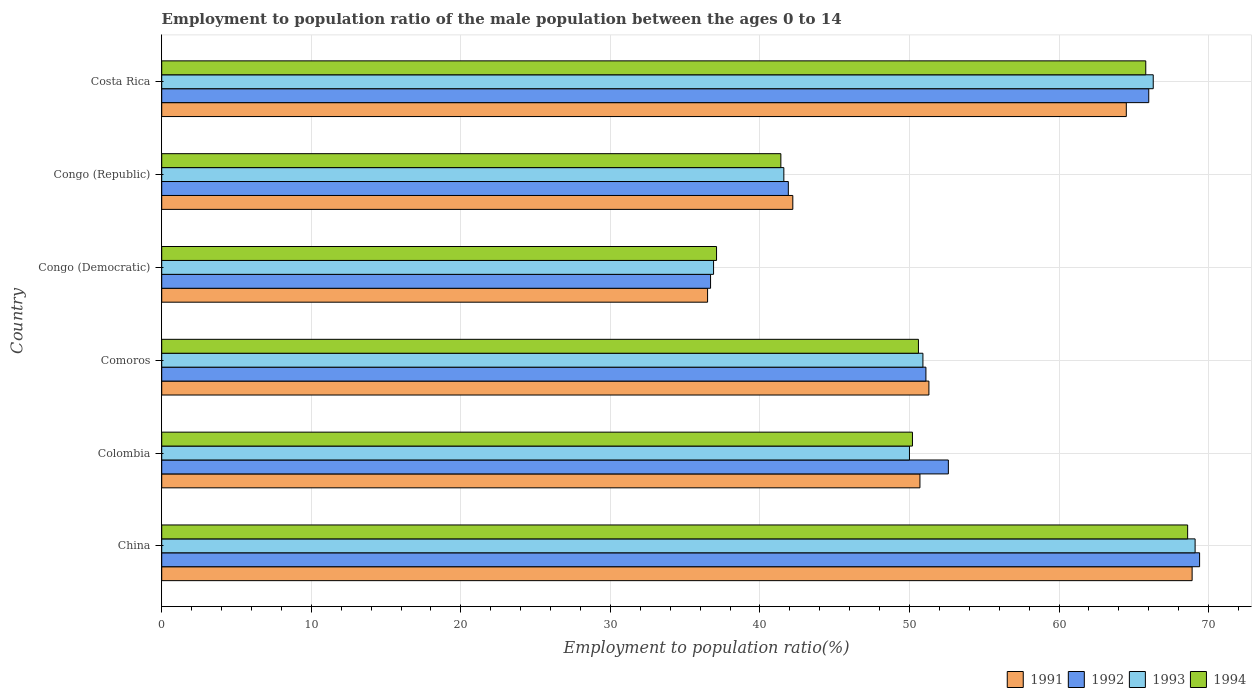Are the number of bars on each tick of the Y-axis equal?
Your answer should be compact. Yes. How many bars are there on the 4th tick from the top?
Make the answer very short. 4. How many bars are there on the 5th tick from the bottom?
Keep it short and to the point. 4. What is the label of the 6th group of bars from the top?
Ensure brevity in your answer.  China. What is the employment to population ratio in 1994 in Comoros?
Keep it short and to the point. 50.6. Across all countries, what is the maximum employment to population ratio in 1994?
Provide a short and direct response. 68.6. Across all countries, what is the minimum employment to population ratio in 1991?
Offer a terse response. 36.5. In which country was the employment to population ratio in 1994 maximum?
Provide a succinct answer. China. In which country was the employment to population ratio in 1991 minimum?
Keep it short and to the point. Congo (Democratic). What is the total employment to population ratio in 1992 in the graph?
Provide a short and direct response. 317.7. What is the difference between the employment to population ratio in 1994 in China and that in Congo (Republic)?
Make the answer very short. 27.2. What is the difference between the employment to population ratio in 1992 in Congo (Republic) and the employment to population ratio in 1994 in China?
Offer a terse response. -26.7. What is the average employment to population ratio in 1991 per country?
Your answer should be very brief. 52.35. What is the ratio of the employment to population ratio in 1992 in China to that in Congo (Democratic)?
Offer a very short reply. 1.89. Is the employment to population ratio in 1994 in Congo (Democratic) less than that in Congo (Republic)?
Ensure brevity in your answer.  Yes. What is the difference between the highest and the second highest employment to population ratio in 1994?
Provide a short and direct response. 2.8. What is the difference between the highest and the lowest employment to population ratio in 1991?
Keep it short and to the point. 32.4. Is the sum of the employment to population ratio in 1994 in Colombia and Comoros greater than the maximum employment to population ratio in 1991 across all countries?
Ensure brevity in your answer.  Yes. Is it the case that in every country, the sum of the employment to population ratio in 1993 and employment to population ratio in 1994 is greater than the sum of employment to population ratio in 1992 and employment to population ratio in 1991?
Keep it short and to the point. No. What does the 3rd bar from the top in Comoros represents?
Make the answer very short. 1992. What does the 2nd bar from the bottom in China represents?
Provide a succinct answer. 1992. How many bars are there?
Give a very brief answer. 24. Are all the bars in the graph horizontal?
Offer a terse response. Yes. Are the values on the major ticks of X-axis written in scientific E-notation?
Offer a very short reply. No. Does the graph contain grids?
Give a very brief answer. Yes. Where does the legend appear in the graph?
Your answer should be very brief. Bottom right. How are the legend labels stacked?
Your response must be concise. Horizontal. What is the title of the graph?
Your response must be concise. Employment to population ratio of the male population between the ages 0 to 14. What is the label or title of the Y-axis?
Provide a short and direct response. Country. What is the Employment to population ratio(%) in 1991 in China?
Make the answer very short. 68.9. What is the Employment to population ratio(%) in 1992 in China?
Your answer should be very brief. 69.4. What is the Employment to population ratio(%) in 1993 in China?
Provide a succinct answer. 69.1. What is the Employment to population ratio(%) in 1994 in China?
Provide a short and direct response. 68.6. What is the Employment to population ratio(%) in 1991 in Colombia?
Make the answer very short. 50.7. What is the Employment to population ratio(%) of 1992 in Colombia?
Ensure brevity in your answer.  52.6. What is the Employment to population ratio(%) of 1994 in Colombia?
Offer a very short reply. 50.2. What is the Employment to population ratio(%) of 1991 in Comoros?
Give a very brief answer. 51.3. What is the Employment to population ratio(%) in 1992 in Comoros?
Make the answer very short. 51.1. What is the Employment to population ratio(%) of 1993 in Comoros?
Provide a succinct answer. 50.9. What is the Employment to population ratio(%) of 1994 in Comoros?
Provide a short and direct response. 50.6. What is the Employment to population ratio(%) in 1991 in Congo (Democratic)?
Make the answer very short. 36.5. What is the Employment to population ratio(%) in 1992 in Congo (Democratic)?
Your answer should be very brief. 36.7. What is the Employment to population ratio(%) of 1993 in Congo (Democratic)?
Provide a succinct answer. 36.9. What is the Employment to population ratio(%) of 1994 in Congo (Democratic)?
Give a very brief answer. 37.1. What is the Employment to population ratio(%) in 1991 in Congo (Republic)?
Offer a very short reply. 42.2. What is the Employment to population ratio(%) in 1992 in Congo (Republic)?
Your response must be concise. 41.9. What is the Employment to population ratio(%) of 1993 in Congo (Republic)?
Your response must be concise. 41.6. What is the Employment to population ratio(%) of 1994 in Congo (Republic)?
Give a very brief answer. 41.4. What is the Employment to population ratio(%) in 1991 in Costa Rica?
Your response must be concise. 64.5. What is the Employment to population ratio(%) in 1992 in Costa Rica?
Ensure brevity in your answer.  66. What is the Employment to population ratio(%) of 1993 in Costa Rica?
Keep it short and to the point. 66.3. What is the Employment to population ratio(%) of 1994 in Costa Rica?
Make the answer very short. 65.8. Across all countries, what is the maximum Employment to population ratio(%) in 1991?
Your answer should be very brief. 68.9. Across all countries, what is the maximum Employment to population ratio(%) of 1992?
Make the answer very short. 69.4. Across all countries, what is the maximum Employment to population ratio(%) in 1993?
Provide a succinct answer. 69.1. Across all countries, what is the maximum Employment to population ratio(%) in 1994?
Give a very brief answer. 68.6. Across all countries, what is the minimum Employment to population ratio(%) of 1991?
Ensure brevity in your answer.  36.5. Across all countries, what is the minimum Employment to population ratio(%) in 1992?
Provide a succinct answer. 36.7. Across all countries, what is the minimum Employment to population ratio(%) of 1993?
Your response must be concise. 36.9. Across all countries, what is the minimum Employment to population ratio(%) of 1994?
Make the answer very short. 37.1. What is the total Employment to population ratio(%) in 1991 in the graph?
Provide a short and direct response. 314.1. What is the total Employment to population ratio(%) of 1992 in the graph?
Ensure brevity in your answer.  317.7. What is the total Employment to population ratio(%) of 1993 in the graph?
Provide a succinct answer. 314.8. What is the total Employment to population ratio(%) of 1994 in the graph?
Your response must be concise. 313.7. What is the difference between the Employment to population ratio(%) of 1994 in China and that in Colombia?
Make the answer very short. 18.4. What is the difference between the Employment to population ratio(%) of 1992 in China and that in Comoros?
Provide a succinct answer. 18.3. What is the difference between the Employment to population ratio(%) of 1991 in China and that in Congo (Democratic)?
Ensure brevity in your answer.  32.4. What is the difference between the Employment to population ratio(%) of 1992 in China and that in Congo (Democratic)?
Your answer should be very brief. 32.7. What is the difference between the Employment to population ratio(%) in 1993 in China and that in Congo (Democratic)?
Your answer should be very brief. 32.2. What is the difference between the Employment to population ratio(%) in 1994 in China and that in Congo (Democratic)?
Provide a short and direct response. 31.5. What is the difference between the Employment to population ratio(%) of 1991 in China and that in Congo (Republic)?
Keep it short and to the point. 26.7. What is the difference between the Employment to population ratio(%) in 1992 in China and that in Congo (Republic)?
Provide a short and direct response. 27.5. What is the difference between the Employment to population ratio(%) of 1994 in China and that in Congo (Republic)?
Give a very brief answer. 27.2. What is the difference between the Employment to population ratio(%) in 1991 in China and that in Costa Rica?
Provide a succinct answer. 4.4. What is the difference between the Employment to population ratio(%) in 1991 in Colombia and that in Comoros?
Your answer should be compact. -0.6. What is the difference between the Employment to population ratio(%) in 1992 in Colombia and that in Congo (Democratic)?
Offer a terse response. 15.9. What is the difference between the Employment to population ratio(%) in 1991 in Colombia and that in Congo (Republic)?
Your answer should be very brief. 8.5. What is the difference between the Employment to population ratio(%) of 1993 in Colombia and that in Congo (Republic)?
Offer a very short reply. 8.4. What is the difference between the Employment to population ratio(%) of 1991 in Colombia and that in Costa Rica?
Make the answer very short. -13.8. What is the difference between the Employment to population ratio(%) of 1993 in Colombia and that in Costa Rica?
Your response must be concise. -16.3. What is the difference between the Employment to population ratio(%) of 1994 in Colombia and that in Costa Rica?
Your answer should be very brief. -15.6. What is the difference between the Employment to population ratio(%) in 1992 in Comoros and that in Congo (Democratic)?
Provide a succinct answer. 14.4. What is the difference between the Employment to population ratio(%) in 1993 in Comoros and that in Congo (Democratic)?
Give a very brief answer. 14. What is the difference between the Employment to population ratio(%) of 1994 in Comoros and that in Congo (Democratic)?
Give a very brief answer. 13.5. What is the difference between the Employment to population ratio(%) of 1991 in Comoros and that in Congo (Republic)?
Provide a short and direct response. 9.1. What is the difference between the Employment to population ratio(%) of 1994 in Comoros and that in Congo (Republic)?
Your answer should be compact. 9.2. What is the difference between the Employment to population ratio(%) of 1991 in Comoros and that in Costa Rica?
Ensure brevity in your answer.  -13.2. What is the difference between the Employment to population ratio(%) of 1992 in Comoros and that in Costa Rica?
Offer a very short reply. -14.9. What is the difference between the Employment to population ratio(%) in 1993 in Comoros and that in Costa Rica?
Provide a succinct answer. -15.4. What is the difference between the Employment to population ratio(%) in 1994 in Comoros and that in Costa Rica?
Provide a succinct answer. -15.2. What is the difference between the Employment to population ratio(%) of 1992 in Congo (Democratic) and that in Congo (Republic)?
Your answer should be compact. -5.2. What is the difference between the Employment to population ratio(%) in 1993 in Congo (Democratic) and that in Congo (Republic)?
Make the answer very short. -4.7. What is the difference between the Employment to population ratio(%) in 1992 in Congo (Democratic) and that in Costa Rica?
Offer a terse response. -29.3. What is the difference between the Employment to population ratio(%) in 1993 in Congo (Democratic) and that in Costa Rica?
Your answer should be compact. -29.4. What is the difference between the Employment to population ratio(%) in 1994 in Congo (Democratic) and that in Costa Rica?
Offer a very short reply. -28.7. What is the difference between the Employment to population ratio(%) of 1991 in Congo (Republic) and that in Costa Rica?
Keep it short and to the point. -22.3. What is the difference between the Employment to population ratio(%) in 1992 in Congo (Republic) and that in Costa Rica?
Offer a terse response. -24.1. What is the difference between the Employment to population ratio(%) of 1993 in Congo (Republic) and that in Costa Rica?
Provide a short and direct response. -24.7. What is the difference between the Employment to population ratio(%) of 1994 in Congo (Republic) and that in Costa Rica?
Give a very brief answer. -24.4. What is the difference between the Employment to population ratio(%) of 1991 in China and the Employment to population ratio(%) of 1994 in Colombia?
Ensure brevity in your answer.  18.7. What is the difference between the Employment to population ratio(%) of 1993 in China and the Employment to population ratio(%) of 1994 in Colombia?
Keep it short and to the point. 18.9. What is the difference between the Employment to population ratio(%) in 1991 in China and the Employment to population ratio(%) in 1993 in Comoros?
Your answer should be very brief. 18. What is the difference between the Employment to population ratio(%) in 1992 in China and the Employment to population ratio(%) in 1993 in Comoros?
Ensure brevity in your answer.  18.5. What is the difference between the Employment to population ratio(%) in 1993 in China and the Employment to population ratio(%) in 1994 in Comoros?
Provide a short and direct response. 18.5. What is the difference between the Employment to population ratio(%) in 1991 in China and the Employment to population ratio(%) in 1992 in Congo (Democratic)?
Your response must be concise. 32.2. What is the difference between the Employment to population ratio(%) in 1991 in China and the Employment to population ratio(%) in 1994 in Congo (Democratic)?
Make the answer very short. 31.8. What is the difference between the Employment to population ratio(%) in 1992 in China and the Employment to population ratio(%) in 1993 in Congo (Democratic)?
Offer a very short reply. 32.5. What is the difference between the Employment to population ratio(%) in 1992 in China and the Employment to population ratio(%) in 1994 in Congo (Democratic)?
Ensure brevity in your answer.  32.3. What is the difference between the Employment to population ratio(%) in 1993 in China and the Employment to population ratio(%) in 1994 in Congo (Democratic)?
Your response must be concise. 32. What is the difference between the Employment to population ratio(%) in 1991 in China and the Employment to population ratio(%) in 1993 in Congo (Republic)?
Give a very brief answer. 27.3. What is the difference between the Employment to population ratio(%) of 1991 in China and the Employment to population ratio(%) of 1994 in Congo (Republic)?
Offer a terse response. 27.5. What is the difference between the Employment to population ratio(%) in 1992 in China and the Employment to population ratio(%) in 1993 in Congo (Republic)?
Provide a succinct answer. 27.8. What is the difference between the Employment to population ratio(%) in 1992 in China and the Employment to population ratio(%) in 1994 in Congo (Republic)?
Provide a short and direct response. 28. What is the difference between the Employment to population ratio(%) in 1993 in China and the Employment to population ratio(%) in 1994 in Congo (Republic)?
Give a very brief answer. 27.7. What is the difference between the Employment to population ratio(%) in 1991 in China and the Employment to population ratio(%) in 1992 in Costa Rica?
Give a very brief answer. 2.9. What is the difference between the Employment to population ratio(%) in 1991 in Colombia and the Employment to population ratio(%) in 1992 in Comoros?
Make the answer very short. -0.4. What is the difference between the Employment to population ratio(%) in 1991 in Colombia and the Employment to population ratio(%) in 1993 in Comoros?
Your response must be concise. -0.2. What is the difference between the Employment to population ratio(%) of 1992 in Colombia and the Employment to population ratio(%) of 1993 in Comoros?
Offer a terse response. 1.7. What is the difference between the Employment to population ratio(%) in 1992 in Colombia and the Employment to population ratio(%) in 1994 in Comoros?
Provide a succinct answer. 2. What is the difference between the Employment to population ratio(%) of 1993 in Colombia and the Employment to population ratio(%) of 1994 in Comoros?
Provide a short and direct response. -0.6. What is the difference between the Employment to population ratio(%) of 1991 in Colombia and the Employment to population ratio(%) of 1992 in Congo (Democratic)?
Ensure brevity in your answer.  14. What is the difference between the Employment to population ratio(%) of 1991 in Colombia and the Employment to population ratio(%) of 1993 in Congo (Republic)?
Your answer should be compact. 9.1. What is the difference between the Employment to population ratio(%) of 1992 in Colombia and the Employment to population ratio(%) of 1994 in Congo (Republic)?
Ensure brevity in your answer.  11.2. What is the difference between the Employment to population ratio(%) in 1991 in Colombia and the Employment to population ratio(%) in 1992 in Costa Rica?
Make the answer very short. -15.3. What is the difference between the Employment to population ratio(%) of 1991 in Colombia and the Employment to population ratio(%) of 1993 in Costa Rica?
Offer a very short reply. -15.6. What is the difference between the Employment to population ratio(%) of 1991 in Colombia and the Employment to population ratio(%) of 1994 in Costa Rica?
Your response must be concise. -15.1. What is the difference between the Employment to population ratio(%) of 1992 in Colombia and the Employment to population ratio(%) of 1993 in Costa Rica?
Offer a terse response. -13.7. What is the difference between the Employment to population ratio(%) of 1993 in Colombia and the Employment to population ratio(%) of 1994 in Costa Rica?
Your response must be concise. -15.8. What is the difference between the Employment to population ratio(%) of 1991 in Comoros and the Employment to population ratio(%) of 1992 in Congo (Democratic)?
Your answer should be compact. 14.6. What is the difference between the Employment to population ratio(%) of 1991 in Comoros and the Employment to population ratio(%) of 1993 in Congo (Democratic)?
Your answer should be compact. 14.4. What is the difference between the Employment to population ratio(%) in 1991 in Comoros and the Employment to population ratio(%) in 1992 in Congo (Republic)?
Your answer should be compact. 9.4. What is the difference between the Employment to population ratio(%) in 1991 in Comoros and the Employment to population ratio(%) in 1992 in Costa Rica?
Provide a short and direct response. -14.7. What is the difference between the Employment to population ratio(%) in 1992 in Comoros and the Employment to population ratio(%) in 1993 in Costa Rica?
Your answer should be very brief. -15.2. What is the difference between the Employment to population ratio(%) of 1992 in Comoros and the Employment to population ratio(%) of 1994 in Costa Rica?
Your response must be concise. -14.7. What is the difference between the Employment to population ratio(%) in 1993 in Comoros and the Employment to population ratio(%) in 1994 in Costa Rica?
Ensure brevity in your answer.  -14.9. What is the difference between the Employment to population ratio(%) in 1991 in Congo (Democratic) and the Employment to population ratio(%) in 1992 in Congo (Republic)?
Your response must be concise. -5.4. What is the difference between the Employment to population ratio(%) of 1992 in Congo (Democratic) and the Employment to population ratio(%) of 1993 in Congo (Republic)?
Make the answer very short. -4.9. What is the difference between the Employment to population ratio(%) in 1991 in Congo (Democratic) and the Employment to population ratio(%) in 1992 in Costa Rica?
Your answer should be compact. -29.5. What is the difference between the Employment to population ratio(%) in 1991 in Congo (Democratic) and the Employment to population ratio(%) in 1993 in Costa Rica?
Ensure brevity in your answer.  -29.8. What is the difference between the Employment to population ratio(%) of 1991 in Congo (Democratic) and the Employment to population ratio(%) of 1994 in Costa Rica?
Your answer should be compact. -29.3. What is the difference between the Employment to population ratio(%) of 1992 in Congo (Democratic) and the Employment to population ratio(%) of 1993 in Costa Rica?
Your answer should be very brief. -29.6. What is the difference between the Employment to population ratio(%) of 1992 in Congo (Democratic) and the Employment to population ratio(%) of 1994 in Costa Rica?
Offer a very short reply. -29.1. What is the difference between the Employment to population ratio(%) of 1993 in Congo (Democratic) and the Employment to population ratio(%) of 1994 in Costa Rica?
Give a very brief answer. -28.9. What is the difference between the Employment to population ratio(%) in 1991 in Congo (Republic) and the Employment to population ratio(%) in 1992 in Costa Rica?
Give a very brief answer. -23.8. What is the difference between the Employment to population ratio(%) of 1991 in Congo (Republic) and the Employment to population ratio(%) of 1993 in Costa Rica?
Offer a very short reply. -24.1. What is the difference between the Employment to population ratio(%) in 1991 in Congo (Republic) and the Employment to population ratio(%) in 1994 in Costa Rica?
Make the answer very short. -23.6. What is the difference between the Employment to population ratio(%) in 1992 in Congo (Republic) and the Employment to population ratio(%) in 1993 in Costa Rica?
Make the answer very short. -24.4. What is the difference between the Employment to population ratio(%) in 1992 in Congo (Republic) and the Employment to population ratio(%) in 1994 in Costa Rica?
Offer a terse response. -23.9. What is the difference between the Employment to population ratio(%) of 1993 in Congo (Republic) and the Employment to population ratio(%) of 1994 in Costa Rica?
Ensure brevity in your answer.  -24.2. What is the average Employment to population ratio(%) of 1991 per country?
Provide a succinct answer. 52.35. What is the average Employment to population ratio(%) in 1992 per country?
Provide a succinct answer. 52.95. What is the average Employment to population ratio(%) in 1993 per country?
Provide a short and direct response. 52.47. What is the average Employment to population ratio(%) in 1994 per country?
Keep it short and to the point. 52.28. What is the difference between the Employment to population ratio(%) of 1991 and Employment to population ratio(%) of 1992 in China?
Your answer should be very brief. -0.5. What is the difference between the Employment to population ratio(%) of 1991 and Employment to population ratio(%) of 1993 in China?
Give a very brief answer. -0.2. What is the difference between the Employment to population ratio(%) in 1992 and Employment to population ratio(%) in 1993 in China?
Offer a terse response. 0.3. What is the difference between the Employment to population ratio(%) of 1993 and Employment to population ratio(%) of 1994 in China?
Make the answer very short. 0.5. What is the difference between the Employment to population ratio(%) in 1991 and Employment to population ratio(%) in 1992 in Colombia?
Offer a very short reply. -1.9. What is the difference between the Employment to population ratio(%) of 1993 and Employment to population ratio(%) of 1994 in Colombia?
Keep it short and to the point. -0.2. What is the difference between the Employment to population ratio(%) in 1991 and Employment to population ratio(%) in 1992 in Comoros?
Provide a short and direct response. 0.2. What is the difference between the Employment to population ratio(%) of 1991 and Employment to population ratio(%) of 1993 in Comoros?
Offer a terse response. 0.4. What is the difference between the Employment to population ratio(%) of 1991 and Employment to population ratio(%) of 1992 in Congo (Democratic)?
Provide a succinct answer. -0.2. What is the difference between the Employment to population ratio(%) in 1991 and Employment to population ratio(%) in 1993 in Congo (Democratic)?
Your answer should be very brief. -0.4. What is the difference between the Employment to population ratio(%) of 1992 and Employment to population ratio(%) of 1993 in Congo (Democratic)?
Your answer should be compact. -0.2. What is the difference between the Employment to population ratio(%) of 1993 and Employment to population ratio(%) of 1994 in Congo (Democratic)?
Provide a short and direct response. -0.2. What is the difference between the Employment to population ratio(%) in 1991 and Employment to population ratio(%) in 1992 in Congo (Republic)?
Your answer should be very brief. 0.3. What is the difference between the Employment to population ratio(%) in 1991 and Employment to population ratio(%) in 1993 in Congo (Republic)?
Your response must be concise. 0.6. What is the difference between the Employment to population ratio(%) of 1991 and Employment to population ratio(%) of 1994 in Congo (Republic)?
Provide a short and direct response. 0.8. What is the difference between the Employment to population ratio(%) of 1992 and Employment to population ratio(%) of 1993 in Congo (Republic)?
Ensure brevity in your answer.  0.3. What is the difference between the Employment to population ratio(%) of 1992 and Employment to population ratio(%) of 1994 in Congo (Republic)?
Ensure brevity in your answer.  0.5. What is the difference between the Employment to population ratio(%) in 1991 and Employment to population ratio(%) in 1992 in Costa Rica?
Your response must be concise. -1.5. What is the difference between the Employment to population ratio(%) in 1991 and Employment to population ratio(%) in 1993 in Costa Rica?
Keep it short and to the point. -1.8. What is the difference between the Employment to population ratio(%) of 1992 and Employment to population ratio(%) of 1993 in Costa Rica?
Your response must be concise. -0.3. What is the difference between the Employment to population ratio(%) in 1992 and Employment to population ratio(%) in 1994 in Costa Rica?
Provide a short and direct response. 0.2. What is the difference between the Employment to population ratio(%) of 1993 and Employment to population ratio(%) of 1994 in Costa Rica?
Your answer should be compact. 0.5. What is the ratio of the Employment to population ratio(%) in 1991 in China to that in Colombia?
Your response must be concise. 1.36. What is the ratio of the Employment to population ratio(%) of 1992 in China to that in Colombia?
Your answer should be compact. 1.32. What is the ratio of the Employment to population ratio(%) of 1993 in China to that in Colombia?
Ensure brevity in your answer.  1.38. What is the ratio of the Employment to population ratio(%) in 1994 in China to that in Colombia?
Your answer should be compact. 1.37. What is the ratio of the Employment to population ratio(%) in 1991 in China to that in Comoros?
Give a very brief answer. 1.34. What is the ratio of the Employment to population ratio(%) in 1992 in China to that in Comoros?
Offer a very short reply. 1.36. What is the ratio of the Employment to population ratio(%) in 1993 in China to that in Comoros?
Make the answer very short. 1.36. What is the ratio of the Employment to population ratio(%) in 1994 in China to that in Comoros?
Your response must be concise. 1.36. What is the ratio of the Employment to population ratio(%) in 1991 in China to that in Congo (Democratic)?
Provide a short and direct response. 1.89. What is the ratio of the Employment to population ratio(%) of 1992 in China to that in Congo (Democratic)?
Ensure brevity in your answer.  1.89. What is the ratio of the Employment to population ratio(%) of 1993 in China to that in Congo (Democratic)?
Your answer should be very brief. 1.87. What is the ratio of the Employment to population ratio(%) of 1994 in China to that in Congo (Democratic)?
Your answer should be compact. 1.85. What is the ratio of the Employment to population ratio(%) in 1991 in China to that in Congo (Republic)?
Your response must be concise. 1.63. What is the ratio of the Employment to population ratio(%) of 1992 in China to that in Congo (Republic)?
Provide a succinct answer. 1.66. What is the ratio of the Employment to population ratio(%) in 1993 in China to that in Congo (Republic)?
Offer a very short reply. 1.66. What is the ratio of the Employment to population ratio(%) in 1994 in China to that in Congo (Republic)?
Provide a short and direct response. 1.66. What is the ratio of the Employment to population ratio(%) in 1991 in China to that in Costa Rica?
Make the answer very short. 1.07. What is the ratio of the Employment to population ratio(%) of 1992 in China to that in Costa Rica?
Make the answer very short. 1.05. What is the ratio of the Employment to population ratio(%) in 1993 in China to that in Costa Rica?
Your response must be concise. 1.04. What is the ratio of the Employment to population ratio(%) in 1994 in China to that in Costa Rica?
Provide a short and direct response. 1.04. What is the ratio of the Employment to population ratio(%) in 1991 in Colombia to that in Comoros?
Offer a very short reply. 0.99. What is the ratio of the Employment to population ratio(%) of 1992 in Colombia to that in Comoros?
Make the answer very short. 1.03. What is the ratio of the Employment to population ratio(%) of 1993 in Colombia to that in Comoros?
Keep it short and to the point. 0.98. What is the ratio of the Employment to population ratio(%) in 1994 in Colombia to that in Comoros?
Provide a short and direct response. 0.99. What is the ratio of the Employment to population ratio(%) of 1991 in Colombia to that in Congo (Democratic)?
Offer a very short reply. 1.39. What is the ratio of the Employment to population ratio(%) in 1992 in Colombia to that in Congo (Democratic)?
Make the answer very short. 1.43. What is the ratio of the Employment to population ratio(%) of 1993 in Colombia to that in Congo (Democratic)?
Ensure brevity in your answer.  1.35. What is the ratio of the Employment to population ratio(%) of 1994 in Colombia to that in Congo (Democratic)?
Keep it short and to the point. 1.35. What is the ratio of the Employment to population ratio(%) of 1991 in Colombia to that in Congo (Republic)?
Your response must be concise. 1.2. What is the ratio of the Employment to population ratio(%) of 1992 in Colombia to that in Congo (Republic)?
Provide a short and direct response. 1.26. What is the ratio of the Employment to population ratio(%) of 1993 in Colombia to that in Congo (Republic)?
Offer a very short reply. 1.2. What is the ratio of the Employment to population ratio(%) in 1994 in Colombia to that in Congo (Republic)?
Offer a very short reply. 1.21. What is the ratio of the Employment to population ratio(%) of 1991 in Colombia to that in Costa Rica?
Offer a very short reply. 0.79. What is the ratio of the Employment to population ratio(%) in 1992 in Colombia to that in Costa Rica?
Keep it short and to the point. 0.8. What is the ratio of the Employment to population ratio(%) of 1993 in Colombia to that in Costa Rica?
Ensure brevity in your answer.  0.75. What is the ratio of the Employment to population ratio(%) of 1994 in Colombia to that in Costa Rica?
Your response must be concise. 0.76. What is the ratio of the Employment to population ratio(%) in 1991 in Comoros to that in Congo (Democratic)?
Ensure brevity in your answer.  1.41. What is the ratio of the Employment to population ratio(%) of 1992 in Comoros to that in Congo (Democratic)?
Make the answer very short. 1.39. What is the ratio of the Employment to population ratio(%) in 1993 in Comoros to that in Congo (Democratic)?
Your answer should be very brief. 1.38. What is the ratio of the Employment to population ratio(%) in 1994 in Comoros to that in Congo (Democratic)?
Your answer should be very brief. 1.36. What is the ratio of the Employment to population ratio(%) of 1991 in Comoros to that in Congo (Republic)?
Your answer should be very brief. 1.22. What is the ratio of the Employment to population ratio(%) in 1992 in Comoros to that in Congo (Republic)?
Offer a terse response. 1.22. What is the ratio of the Employment to population ratio(%) in 1993 in Comoros to that in Congo (Republic)?
Your response must be concise. 1.22. What is the ratio of the Employment to population ratio(%) of 1994 in Comoros to that in Congo (Republic)?
Provide a succinct answer. 1.22. What is the ratio of the Employment to population ratio(%) in 1991 in Comoros to that in Costa Rica?
Ensure brevity in your answer.  0.8. What is the ratio of the Employment to population ratio(%) in 1992 in Comoros to that in Costa Rica?
Ensure brevity in your answer.  0.77. What is the ratio of the Employment to population ratio(%) of 1993 in Comoros to that in Costa Rica?
Offer a very short reply. 0.77. What is the ratio of the Employment to population ratio(%) of 1994 in Comoros to that in Costa Rica?
Offer a terse response. 0.77. What is the ratio of the Employment to population ratio(%) of 1991 in Congo (Democratic) to that in Congo (Republic)?
Make the answer very short. 0.86. What is the ratio of the Employment to population ratio(%) of 1992 in Congo (Democratic) to that in Congo (Republic)?
Make the answer very short. 0.88. What is the ratio of the Employment to population ratio(%) of 1993 in Congo (Democratic) to that in Congo (Republic)?
Ensure brevity in your answer.  0.89. What is the ratio of the Employment to population ratio(%) of 1994 in Congo (Democratic) to that in Congo (Republic)?
Provide a succinct answer. 0.9. What is the ratio of the Employment to population ratio(%) in 1991 in Congo (Democratic) to that in Costa Rica?
Offer a very short reply. 0.57. What is the ratio of the Employment to population ratio(%) in 1992 in Congo (Democratic) to that in Costa Rica?
Offer a very short reply. 0.56. What is the ratio of the Employment to population ratio(%) of 1993 in Congo (Democratic) to that in Costa Rica?
Provide a short and direct response. 0.56. What is the ratio of the Employment to population ratio(%) in 1994 in Congo (Democratic) to that in Costa Rica?
Your answer should be very brief. 0.56. What is the ratio of the Employment to population ratio(%) of 1991 in Congo (Republic) to that in Costa Rica?
Give a very brief answer. 0.65. What is the ratio of the Employment to population ratio(%) of 1992 in Congo (Republic) to that in Costa Rica?
Your response must be concise. 0.63. What is the ratio of the Employment to population ratio(%) in 1993 in Congo (Republic) to that in Costa Rica?
Your answer should be compact. 0.63. What is the ratio of the Employment to population ratio(%) of 1994 in Congo (Republic) to that in Costa Rica?
Your answer should be very brief. 0.63. What is the difference between the highest and the second highest Employment to population ratio(%) in 1994?
Give a very brief answer. 2.8. What is the difference between the highest and the lowest Employment to population ratio(%) of 1991?
Provide a succinct answer. 32.4. What is the difference between the highest and the lowest Employment to population ratio(%) in 1992?
Provide a short and direct response. 32.7. What is the difference between the highest and the lowest Employment to population ratio(%) in 1993?
Offer a very short reply. 32.2. What is the difference between the highest and the lowest Employment to population ratio(%) in 1994?
Keep it short and to the point. 31.5. 